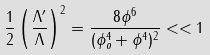Convert formula to latex. <formula><loc_0><loc_0><loc_500><loc_500>\frac { 1 } { 2 } \left ( \frac { \Lambda ^ { \prime } } { \Lambda } \right ) ^ { 2 } = \frac { 8 \phi ^ { 6 } } { ( \phi _ { o } ^ { 4 } + \phi ^ { 4 } ) ^ { 2 } } < < 1</formula> 